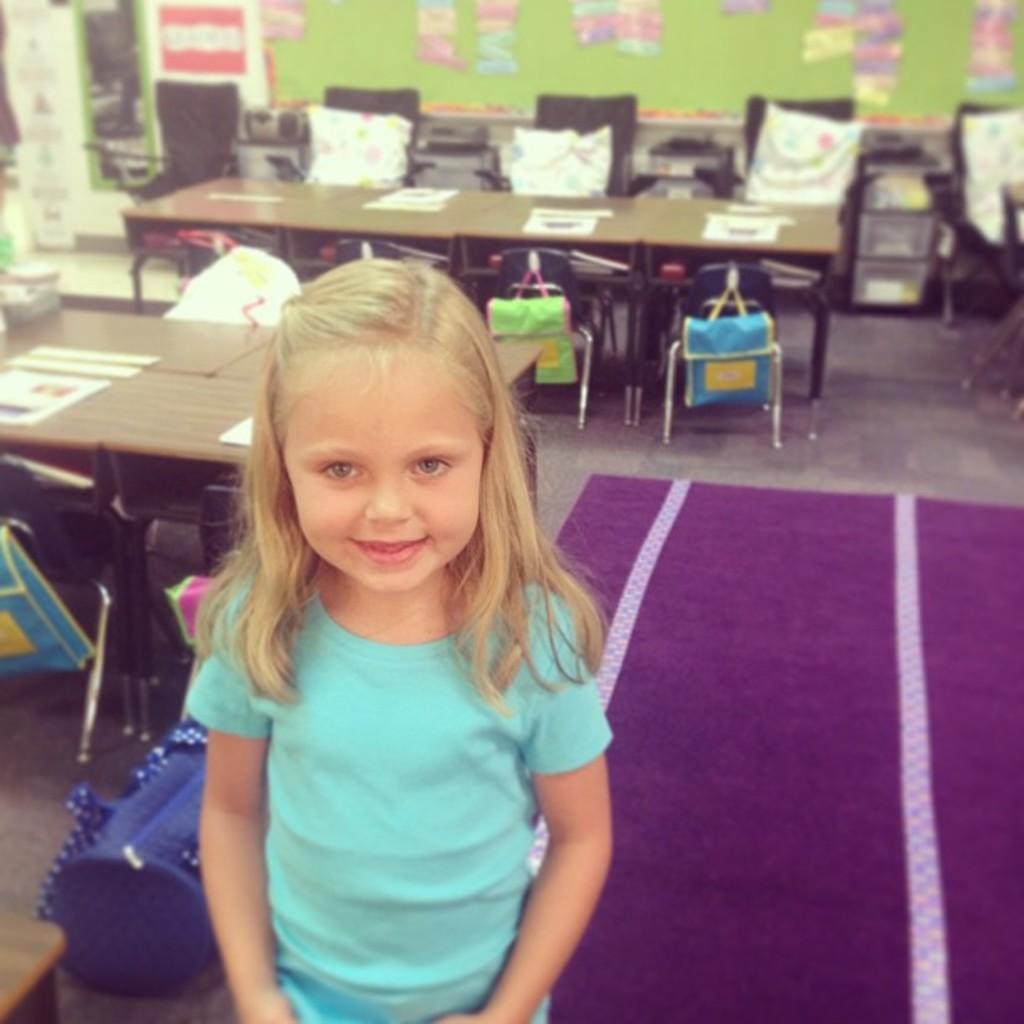Could you give a brief overview of what you see in this image? This Image is clicked in a room where there are so many tables and chairs. There are papers pasted on the wall on the top. There is a carpet in the bottom on the right side. There is a child standing who is wearing green color t-shirt. There is a bag beside her. 